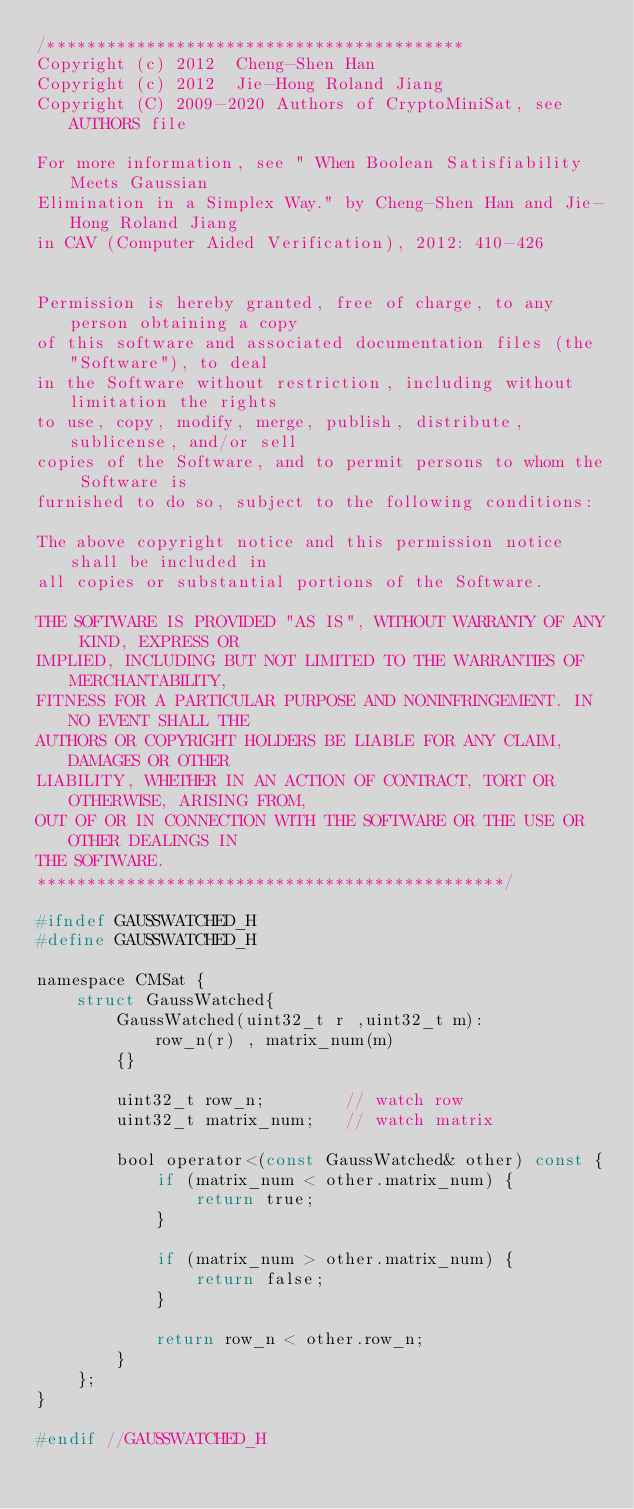<code> <loc_0><loc_0><loc_500><loc_500><_C_>/******************************************
Copyright (c) 2012  Cheng-Shen Han
Copyright (c) 2012  Jie-Hong Roland Jiang
Copyright (C) 2009-2020 Authors of CryptoMiniSat, see AUTHORS file

For more information, see " When Boolean Satisfiability Meets Gaussian
Elimination in a Simplex Way." by Cheng-Shen Han and Jie-Hong Roland Jiang
in CAV (Computer Aided Verification), 2012: 410-426


Permission is hereby granted, free of charge, to any person obtaining a copy
of this software and associated documentation files (the "Software"), to deal
in the Software without restriction, including without limitation the rights
to use, copy, modify, merge, publish, distribute, sublicense, and/or sell
copies of the Software, and to permit persons to whom the Software is
furnished to do so, subject to the following conditions:

The above copyright notice and this permission notice shall be included in
all copies or substantial portions of the Software.

THE SOFTWARE IS PROVIDED "AS IS", WITHOUT WARRANTY OF ANY KIND, EXPRESS OR
IMPLIED, INCLUDING BUT NOT LIMITED TO THE WARRANTIES OF MERCHANTABILITY,
FITNESS FOR A PARTICULAR PURPOSE AND NONINFRINGEMENT. IN NO EVENT SHALL THE
AUTHORS OR COPYRIGHT HOLDERS BE LIABLE FOR ANY CLAIM, DAMAGES OR OTHER
LIABILITY, WHETHER IN AN ACTION OF CONTRACT, TORT OR OTHERWISE, ARISING FROM,
OUT OF OR IN CONNECTION WITH THE SOFTWARE OR THE USE OR OTHER DEALINGS IN
THE SOFTWARE.
***********************************************/

#ifndef GAUSSWATCHED_H
#define GAUSSWATCHED_H

namespace CMSat {
    struct GaussWatched{
        GaussWatched(uint32_t r ,uint32_t m):
            row_n(r) , matrix_num(m)
        {}

        uint32_t row_n;        // watch row
        uint32_t matrix_num;   // watch matrix

        bool operator<(const GaussWatched& other) const {
            if (matrix_num < other.matrix_num) {
                return true;
            }

            if (matrix_num > other.matrix_num) {
                return false;
            }

            return row_n < other.row_n;
        }
    };
}

#endif //GAUSSWATCHED_H
</code> 